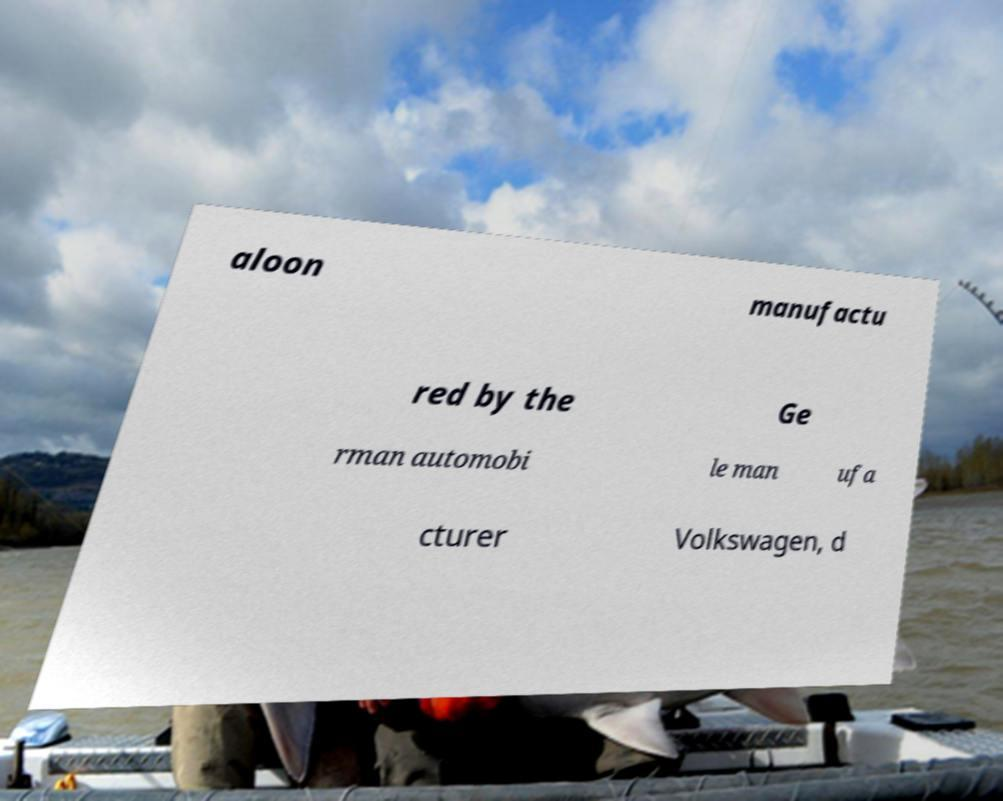Could you extract and type out the text from this image? aloon manufactu red by the Ge rman automobi le man ufa cturer Volkswagen, d 